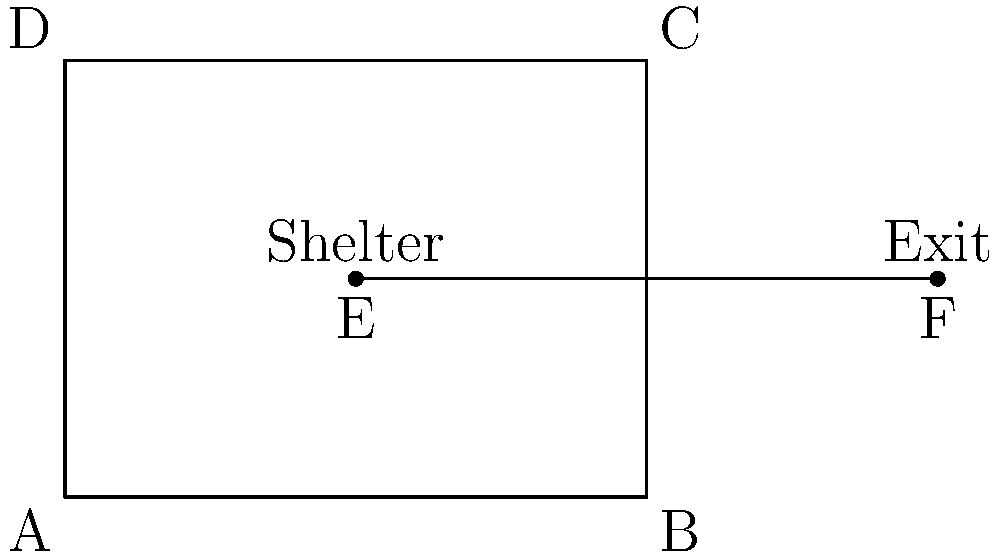In the tornado safety plan evacuation route map of your college dorm, the rectangular floor plan ABCD represents the main hall. Point E represents the shelter location, and point F represents the emergency exit. If $\overline{AE} \cong \overline{BF}$ and $\triangle ADE \cong \triangle BCF$, what is the length of $\overline{EF}$, given that $AB = 4$ units? Let's approach this step-by-step:

1) Given that $\triangle ADE \cong \triangle BCF$, we know that corresponding sides are equal. This means $\overline{DE} \cong \overline{CF}$.

2) We're also given that $\overline{AE} \cong \overline{BF}$. This, combined with the congruence of the triangles, tells us that E and F are equidistant from A and B respectively.

3) Since E and F are equidistant from the ends of AB, $\overline{EF}$ must be parallel to $\overline{AB}$.

4) The length of $\overline{AB}$ is given as 4 units.

5) In a rectangle, opposite sides are parallel and equal. So, $\overline{DC} \parallel \overline{AB}$ and $\overline{DC} = \overline{AB} = 4$ units.

6) Now, $\overline{EF}$ is a line segment parallel to both $\overline{AB}$ and $\overline{DC}$, and it's located between them.

7) In a rectangle, any line segment parallel to a side and connecting the other two sides will have the same length as the side it's parallel to.

Therefore, $\overline{EF}$ must have the same length as $\overline{AB}$ and $\overline{DC}$, which is 4 units.
Answer: 4 units 